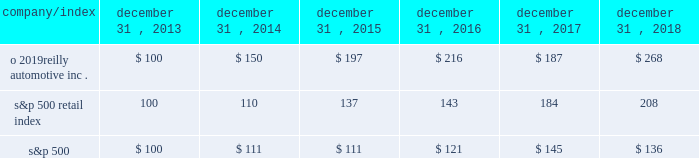Stock performance graph : the graph below shows the cumulative total shareholder return assuming the investment of $ 100 , on december 31 , 2013 , and the reinvestment of dividends thereafter , if any , in the company 2019s common stock versus the standard and poor 2019s s&p 500 retail index ( 201cs&p 500 retail index 201d ) and the standard and poor 2019s s&p 500 index ( 201cs&p 500 201d ) . .

Did the five year return on o 2019reilly automotive inc . outperform the s&p 500 retail index? 
Computations: (268 > 208)
Answer: yes. 